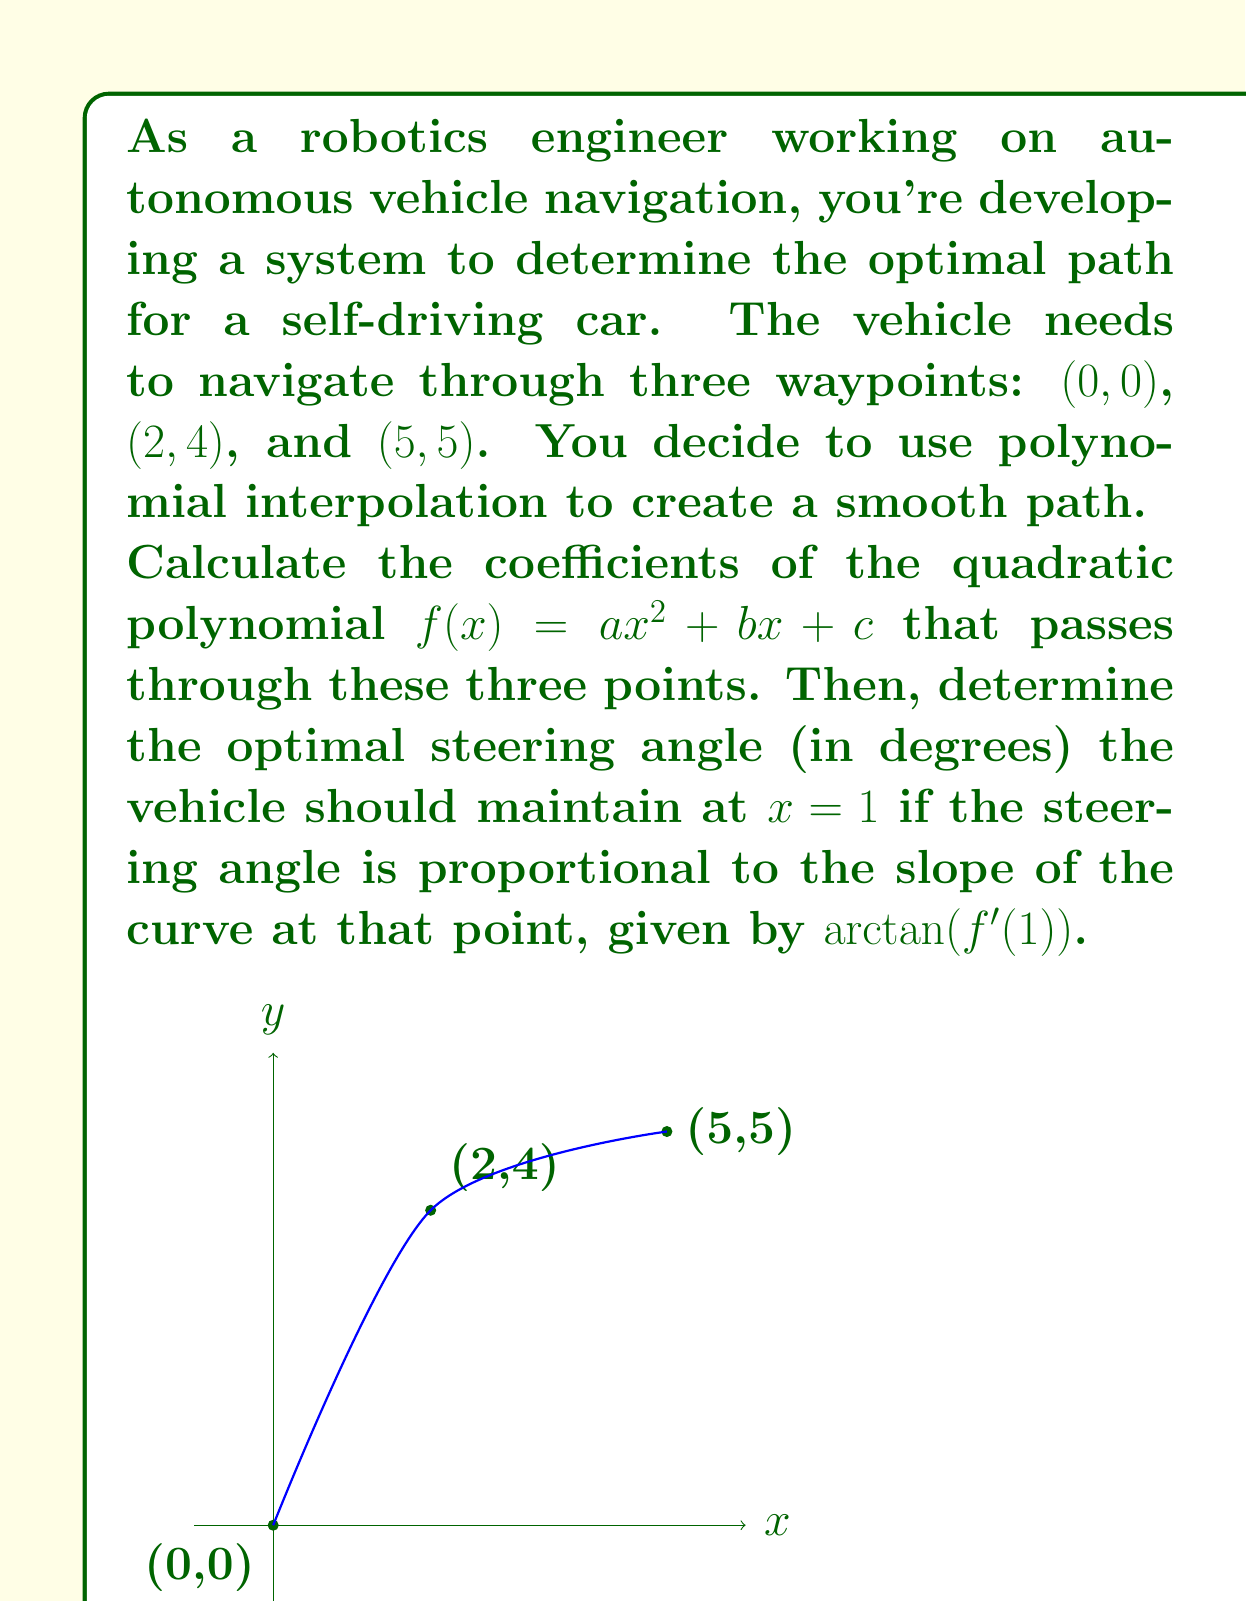Help me with this question. Let's approach this problem step-by-step:

1) We need to find a quadratic function $f(x) = ax^2 + bx + c$ that passes through the points $(0, 0)$, $(2, 4)$, and $(5, 5)$.

2) Substituting these points into the general equation:
   $$(0, 0): c = 0$$
   $$(2, 4): 4a + 2b + c = 4$$
   $$(5, 5): 25a + 5b + c = 5$$

3) Since $c = 0$, we can simplify the other two equations:
   $$4a + 2b = 4$$
   $$25a + 5b = 5$$

4) Multiply the first equation by 5 and the second by -2:
   $$20a + 10b = 20$$
   $$-50a - 10b = -10$$

5) Add these equations:
   $$-30a = 10$$
   $$a = -\frac{1}{3}$$

6) Substitute this back into $4a + 2b = 4$:
   $$4(-\frac{1}{3}) + 2b = 4$$
   $$-\frac{4}{3} + 2b = 4$$
   $$2b = \frac{16}{3}$$
   $$b = \frac{8}{3}$$

7) Therefore, the quadratic function is:
   $$f(x) = -\frac{1}{3}x^2 + \frac{8}{3}x$$

8) To find the optimal steering angle at $x = 1$, we need to calculate $f'(1)$:
   $$f'(x) = -\frac{2}{3}x + \frac{8}{3}$$
   $$f'(1) = -\frac{2}{3} + \frac{8}{3} = 2$$

9) The steering angle is given by $\arctan(f'(1))$:
   $$\text{Steering angle} = \arctan(2) \approx 63.43^\circ$$
Answer: The quadratic polynomial is $f(x) = -\frac{1}{3}x^2 + \frac{8}{3}x$, and the optimal steering angle at $x = 1$ is approximately $63.43^\circ$. 